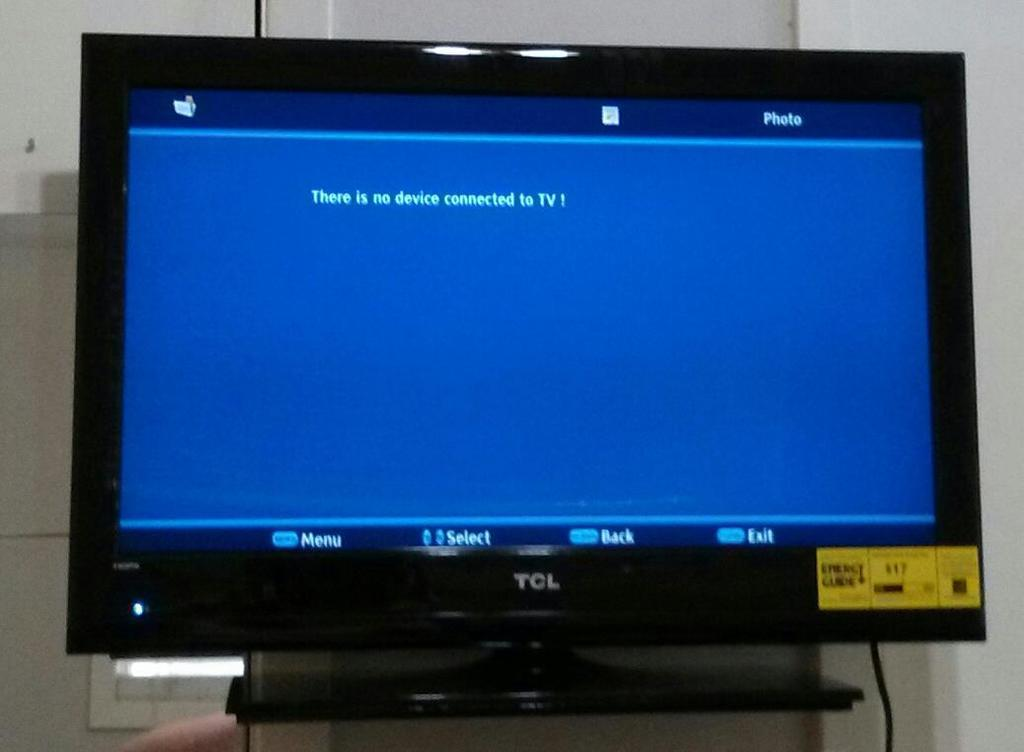<image>
Present a compact description of the photo's key features. a screen that says there is no connected tv 